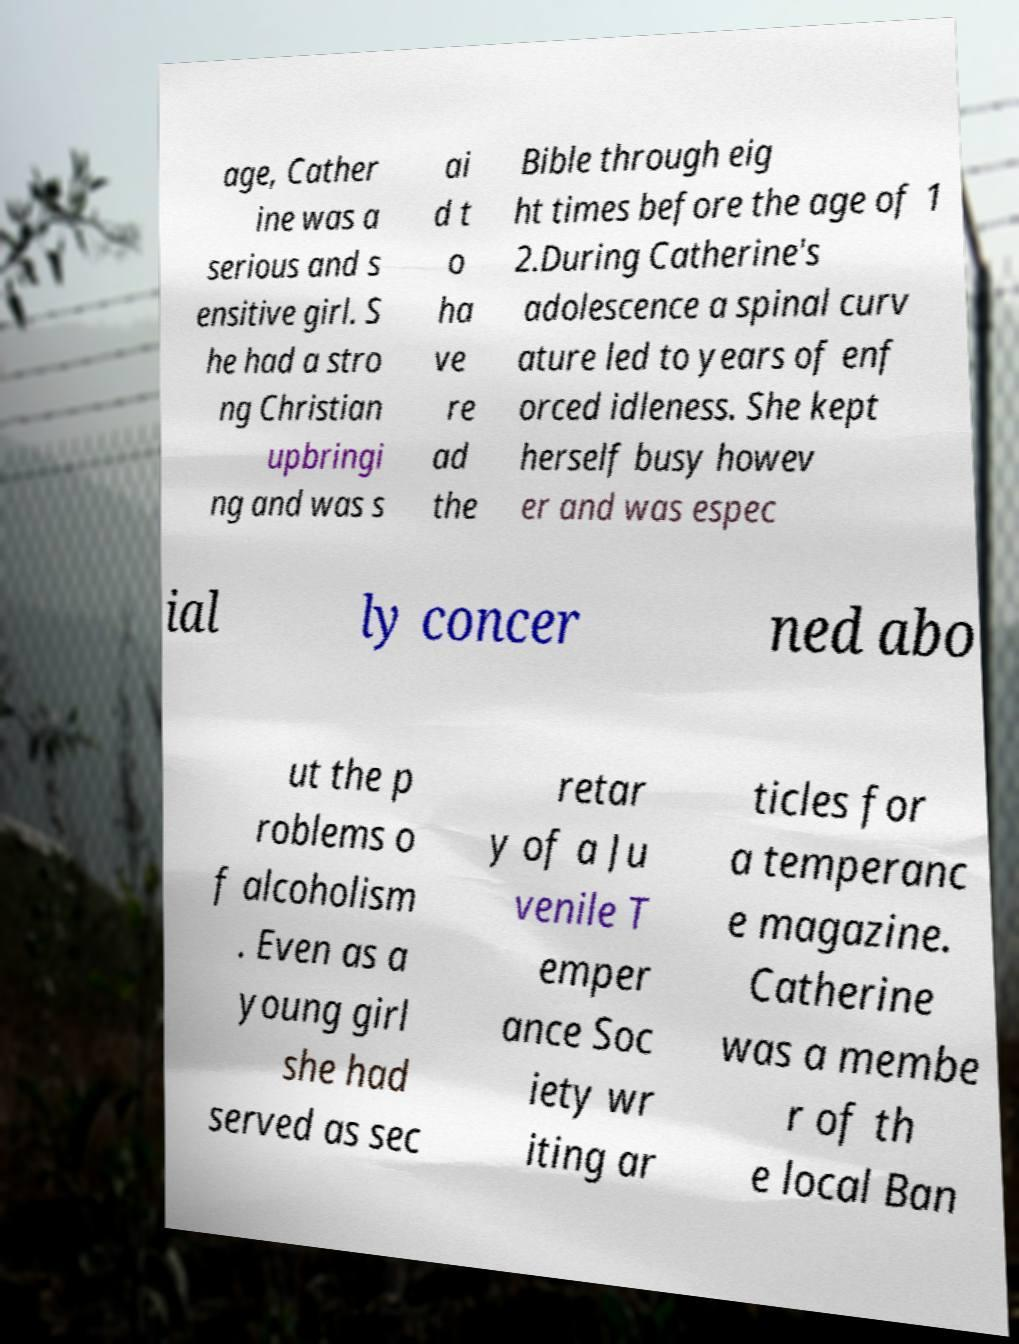What messages or text are displayed in this image? I need them in a readable, typed format. age, Cather ine was a serious and s ensitive girl. S he had a stro ng Christian upbringi ng and was s ai d t o ha ve re ad the Bible through eig ht times before the age of 1 2.During Catherine's adolescence a spinal curv ature led to years of enf orced idleness. She kept herself busy howev er and was espec ial ly concer ned abo ut the p roblems o f alcoholism . Even as a young girl she had served as sec retar y of a Ju venile T emper ance Soc iety wr iting ar ticles for a temperanc e magazine. Catherine was a membe r of th e local Ban 